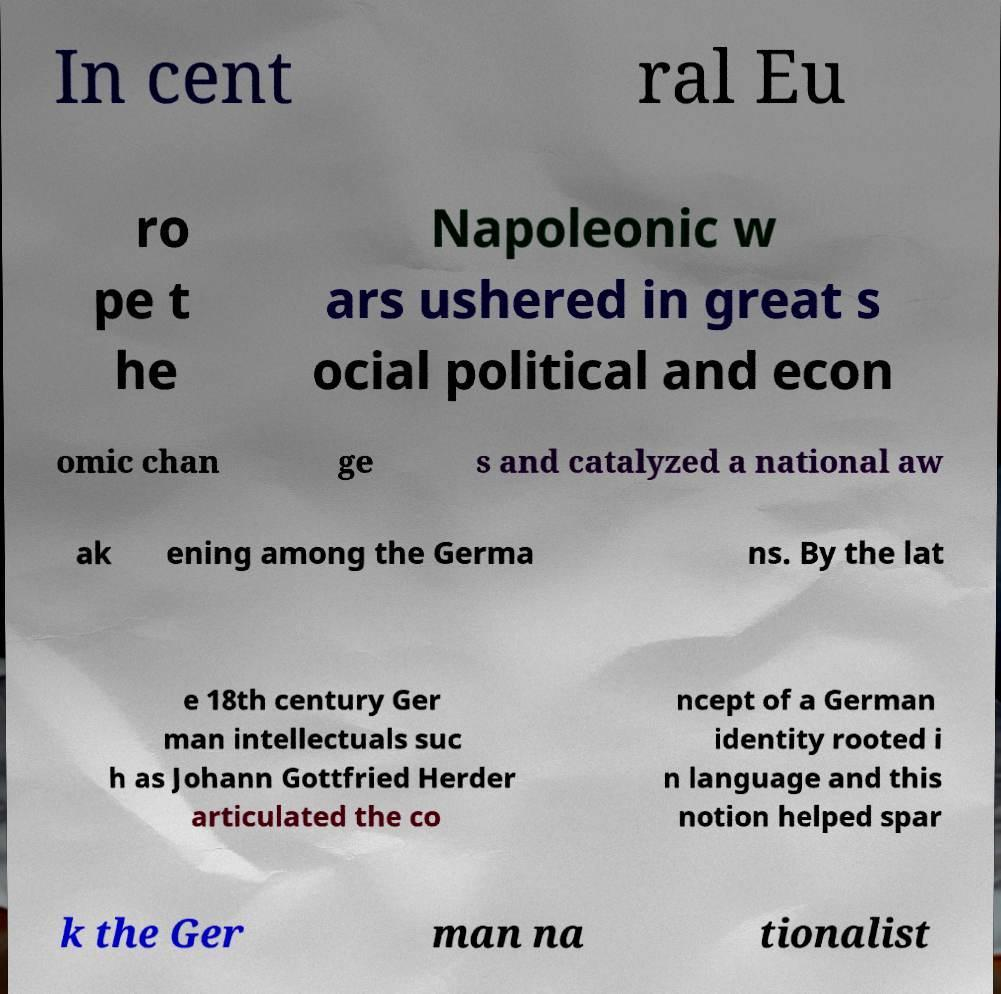Please read and relay the text visible in this image. What does it say? In cent ral Eu ro pe t he Napoleonic w ars ushered in great s ocial political and econ omic chan ge s and catalyzed a national aw ak ening among the Germa ns. By the lat e 18th century Ger man intellectuals suc h as Johann Gottfried Herder articulated the co ncept of a German identity rooted i n language and this notion helped spar k the Ger man na tionalist 